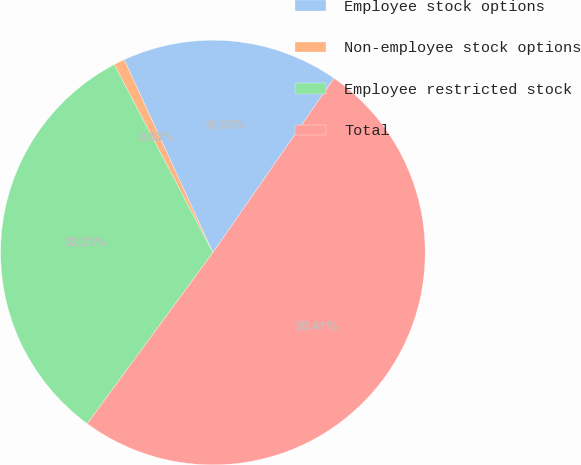Convert chart. <chart><loc_0><loc_0><loc_500><loc_500><pie_chart><fcel>Employee stock options<fcel>Non-employee stock options<fcel>Employee restricted stock<fcel>Total<nl><fcel>16.53%<fcel>0.83%<fcel>32.23%<fcel>50.41%<nl></chart> 